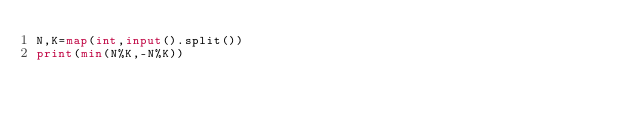Convert code to text. <code><loc_0><loc_0><loc_500><loc_500><_Python_>N,K=map(int,input().split())
print(min(N%K,-N%K))</code> 